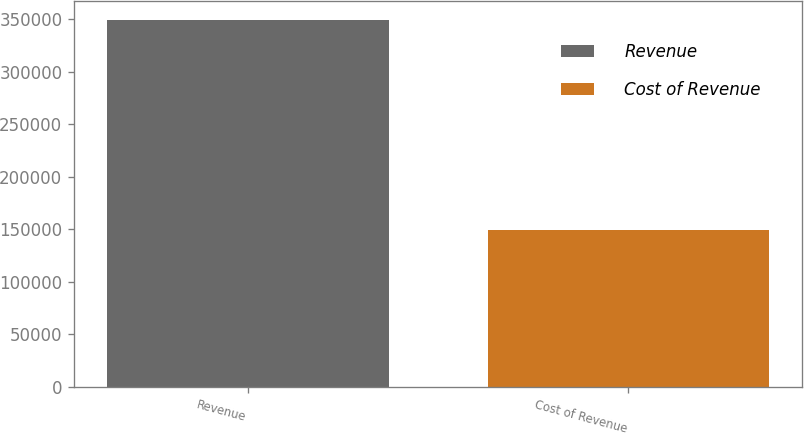<chart> <loc_0><loc_0><loc_500><loc_500><bar_chart><fcel>Revenue<fcel>Cost of Revenue<nl><fcel>349616<fcel>148906<nl></chart> 